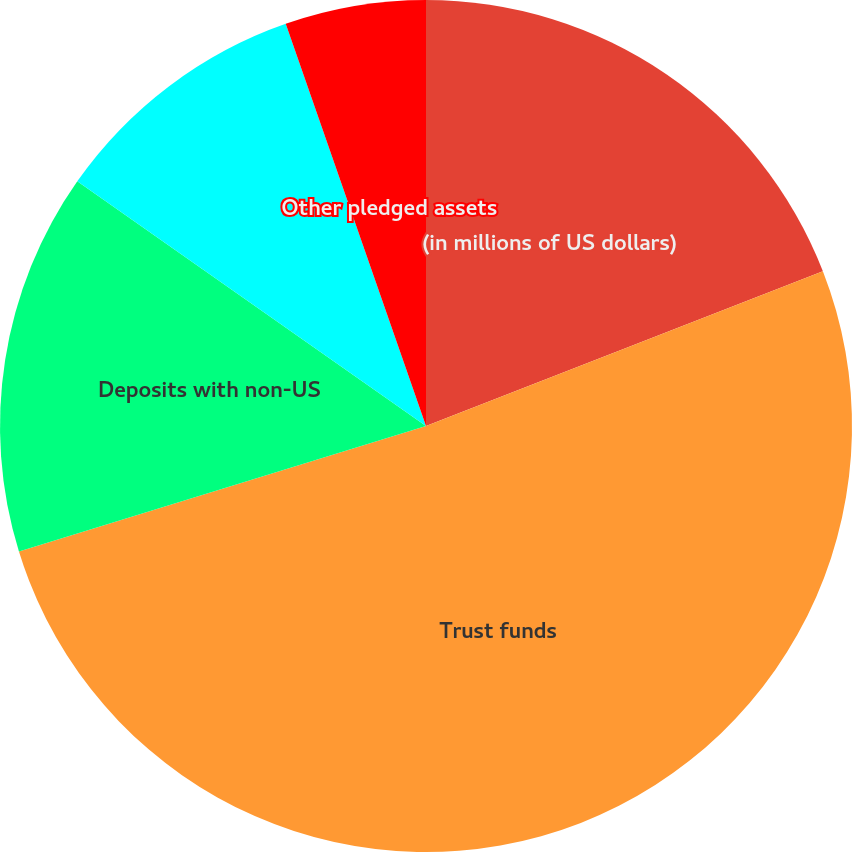Convert chart. <chart><loc_0><loc_0><loc_500><loc_500><pie_chart><fcel>(in millions of US dollars)<fcel>Trust funds<fcel>Deposits with non-US<fcel>Deposits with US regulatory<fcel>Other pledged assets<nl><fcel>19.08%<fcel>51.15%<fcel>14.5%<fcel>9.92%<fcel>5.34%<nl></chart> 